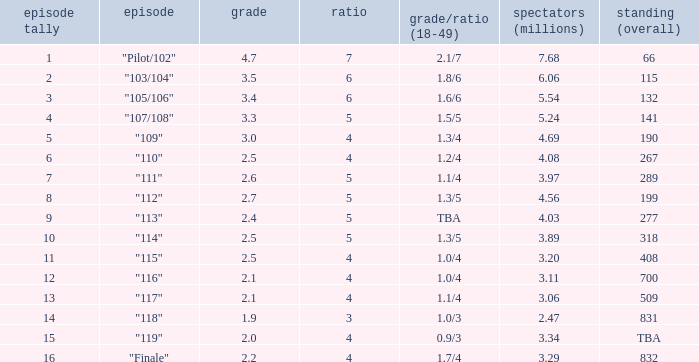WHAT IS THE HIGHEST VIEWERS WITH AN EPISODE LESS THAN 15 AND SHARE LAGER THAN 7? None. 